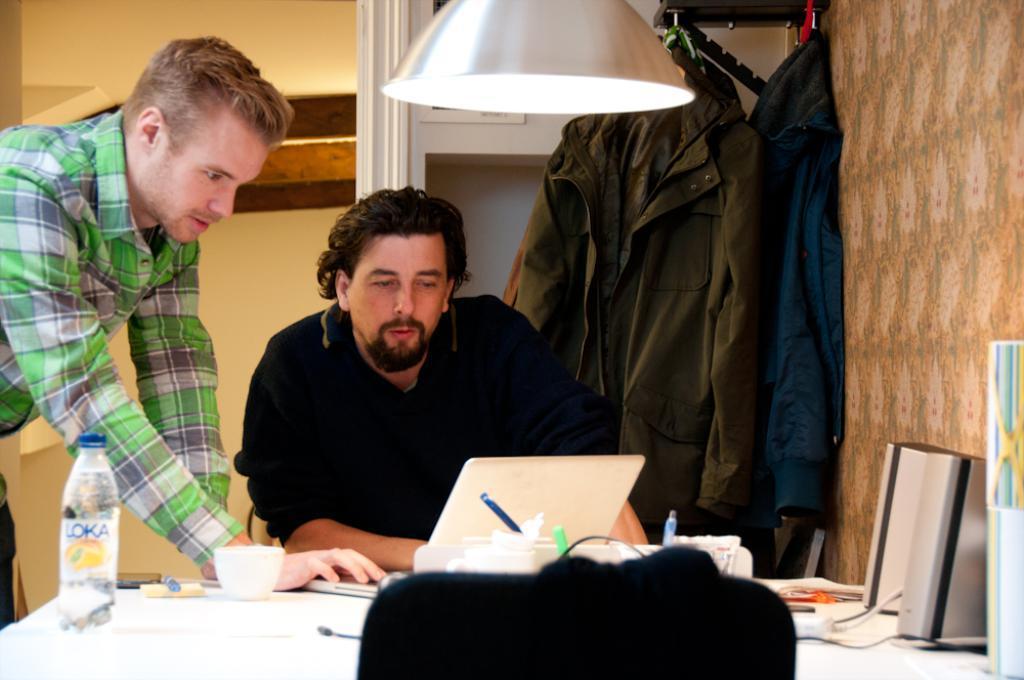Could you give a brief overview of what you see in this image? In this picture we can see two men, one man is standing and one is sitting, the two persons are looking at laptop, there is a table in front of the man, the table consists of a water bottle a cup, on the right side of the image we can see some clothes here, on the top of the image we can see a light. 